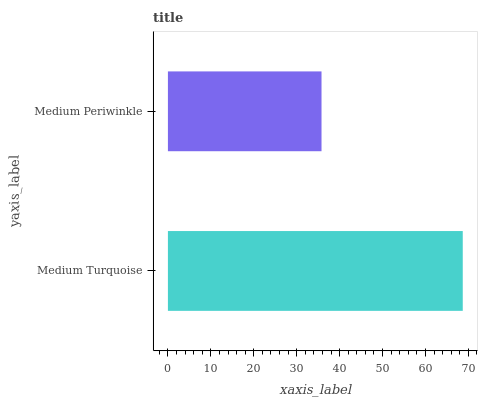Is Medium Periwinkle the minimum?
Answer yes or no. Yes. Is Medium Turquoise the maximum?
Answer yes or no. Yes. Is Medium Periwinkle the maximum?
Answer yes or no. No. Is Medium Turquoise greater than Medium Periwinkle?
Answer yes or no. Yes. Is Medium Periwinkle less than Medium Turquoise?
Answer yes or no. Yes. Is Medium Periwinkle greater than Medium Turquoise?
Answer yes or no. No. Is Medium Turquoise less than Medium Periwinkle?
Answer yes or no. No. Is Medium Turquoise the high median?
Answer yes or no. Yes. Is Medium Periwinkle the low median?
Answer yes or no. Yes. Is Medium Periwinkle the high median?
Answer yes or no. No. Is Medium Turquoise the low median?
Answer yes or no. No. 